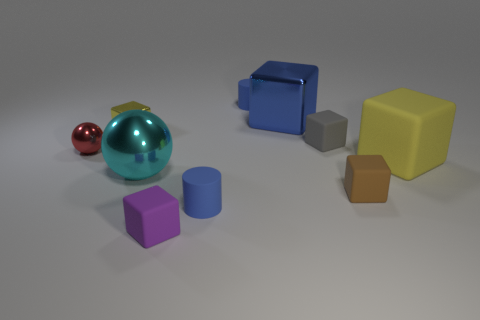What number of other objects have the same color as the big matte object?
Make the answer very short. 1. The large cyan thing is what shape?
Provide a succinct answer. Sphere. There is a tiny thing that is both in front of the gray matte block and to the left of the purple matte cube; what is its color?
Give a very brief answer. Red. What is the material of the small purple thing?
Ensure brevity in your answer.  Rubber. What shape is the tiny metallic thing behind the red thing?
Ensure brevity in your answer.  Cube. There is a matte cube that is the same size as the cyan object; what is its color?
Give a very brief answer. Yellow. Do the small blue thing in front of the red thing and the gray object have the same material?
Ensure brevity in your answer.  Yes. What size is the matte block that is both in front of the tiny gray block and behind the big cyan ball?
Provide a short and direct response. Large. There is a rubber cylinder behind the tiny gray rubber object; how big is it?
Give a very brief answer. Small. There is a thing that is the same color as the small shiny block; what shape is it?
Offer a very short reply. Cube. 